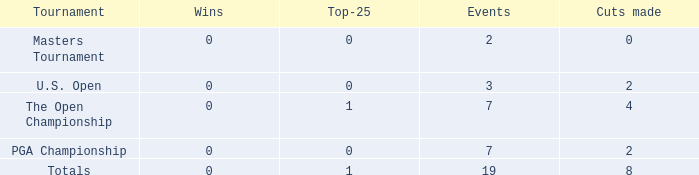What is the total number of cuts made of tournaments with 2 Events? 1.0. 